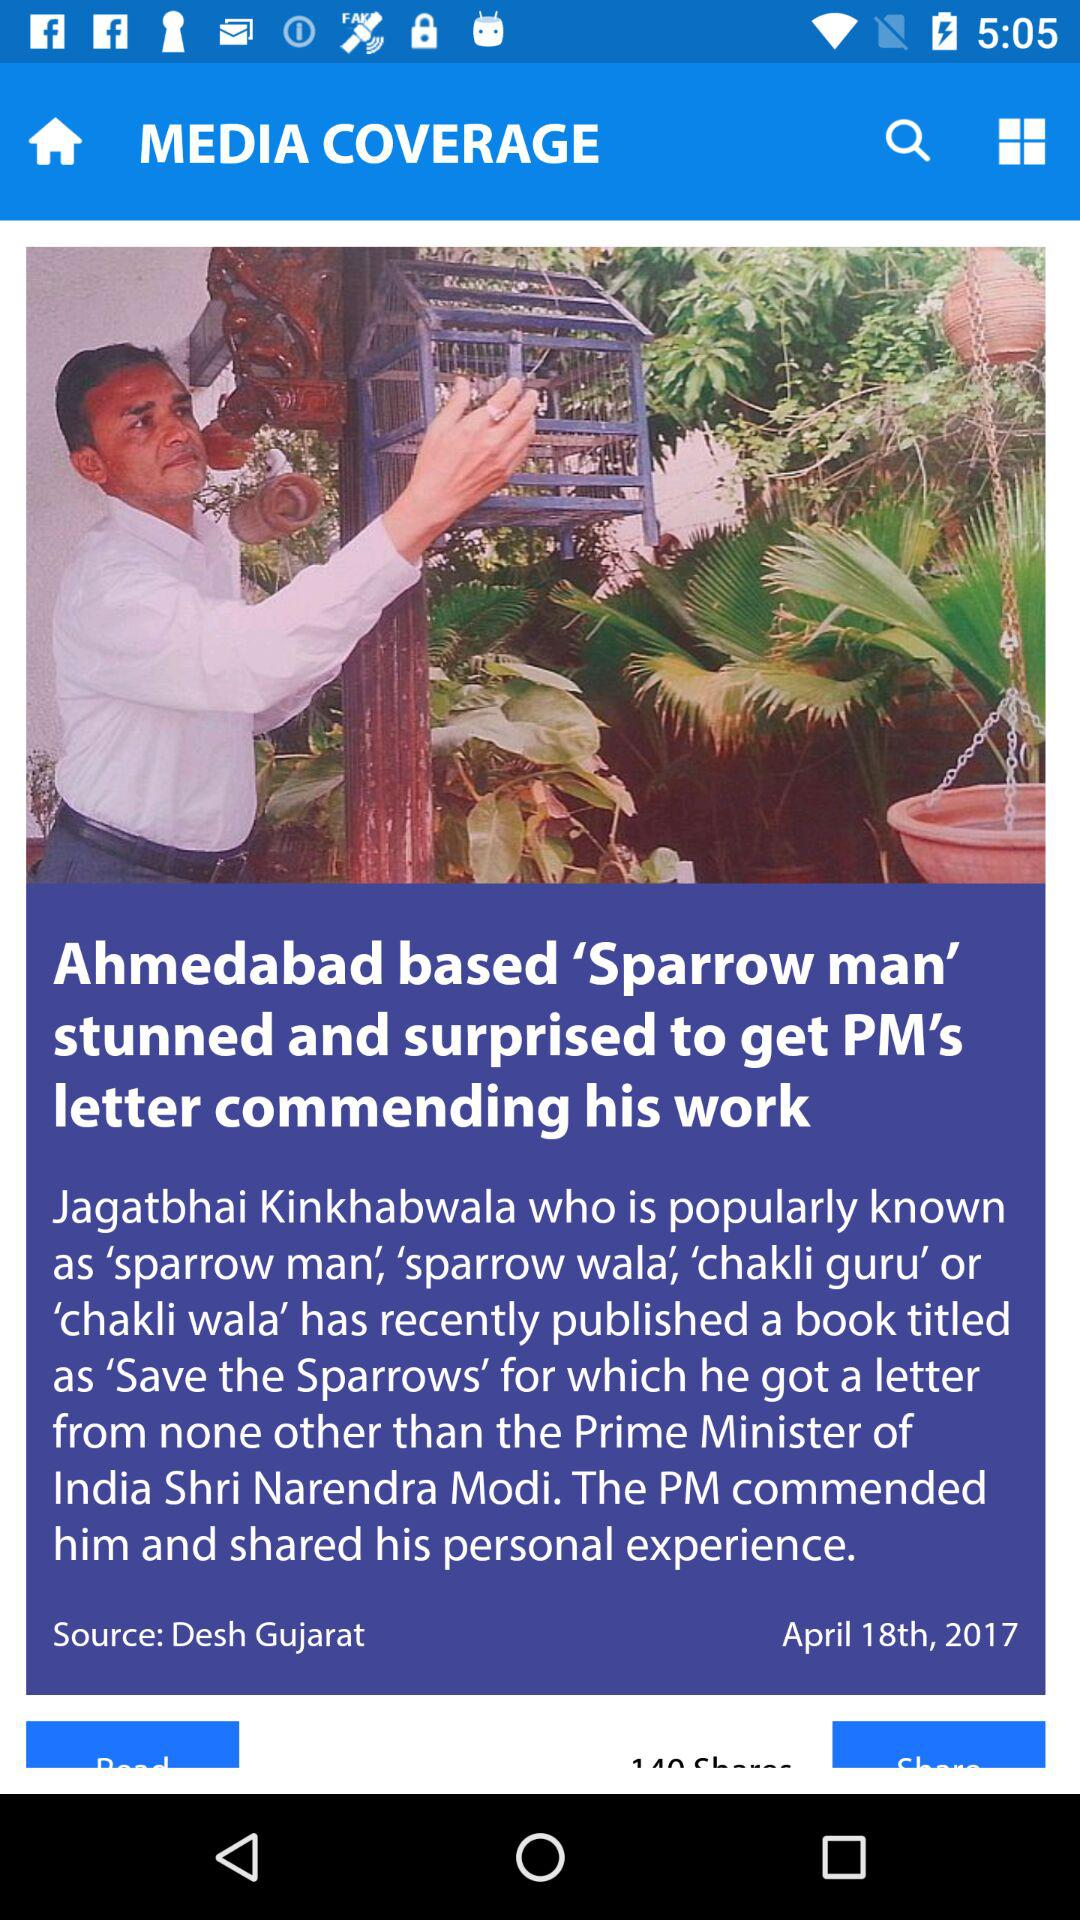Who is known as "Sparrow man"? The person who is known as "Sparrow man" is Jagatbhai Kinkhabwala. 